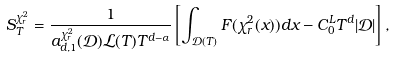<formula> <loc_0><loc_0><loc_500><loc_500>S _ { T } ^ { \chi _ { r } ^ { 2 } } = \frac { 1 } { a _ { d , 1 } ^ { \chi _ { r } ^ { 2 } } ( \mathcal { D } ) \mathcal { L } ( T ) T ^ { d - \alpha } } \left [ \int _ { \mathcal { D } ( T ) } F ( \chi _ { r } ^ { 2 } ( x ) ) d x - C _ { 0 } ^ { L } T ^ { d } | \mathcal { D } | \right ] ,</formula> 